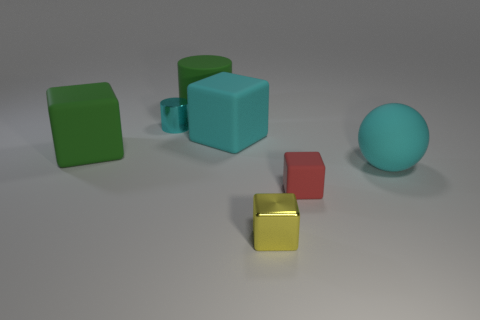Subtract all yellow cubes. How many cubes are left? 3 Subtract all tiny yellow blocks. How many blocks are left? 3 Subtract 2 cubes. How many cubes are left? 2 Add 1 small green shiny objects. How many objects exist? 8 Subtract all brown cubes. Subtract all brown spheres. How many cubes are left? 4 Subtract all cylinders. How many objects are left? 5 Add 7 large cylinders. How many large cylinders exist? 8 Subtract 0 brown spheres. How many objects are left? 7 Subtract all tiny purple shiny cylinders. Subtract all small yellow shiny things. How many objects are left? 6 Add 2 green rubber things. How many green rubber things are left? 4 